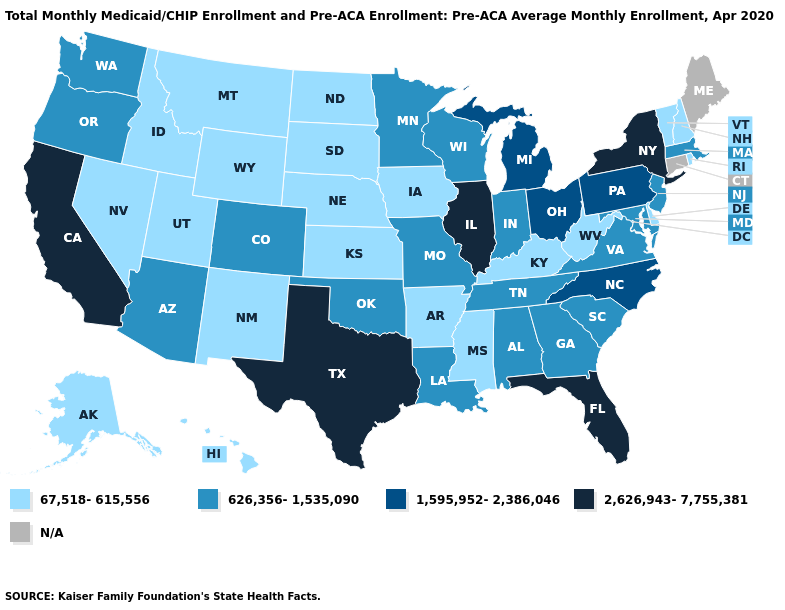What is the value of Arkansas?
Short answer required. 67,518-615,556. What is the value of Kentucky?
Keep it brief. 67,518-615,556. What is the lowest value in states that border West Virginia?
Be succinct. 67,518-615,556. Which states have the highest value in the USA?
Answer briefly. California, Florida, Illinois, New York, Texas. Does the map have missing data?
Quick response, please. Yes. Does Illinois have the highest value in the USA?
Quick response, please. Yes. Which states hav the highest value in the MidWest?
Give a very brief answer. Illinois. Is the legend a continuous bar?
Answer briefly. No. Among the states that border Tennessee , which have the highest value?
Short answer required. North Carolina. Among the states that border Delaware , which have the lowest value?
Concise answer only. Maryland, New Jersey. Name the states that have a value in the range 1,595,952-2,386,046?
Give a very brief answer. Michigan, North Carolina, Ohio, Pennsylvania. Does the map have missing data?
Short answer required. Yes. What is the value of New York?
Concise answer only. 2,626,943-7,755,381. Does California have the highest value in the West?
Be succinct. Yes. 